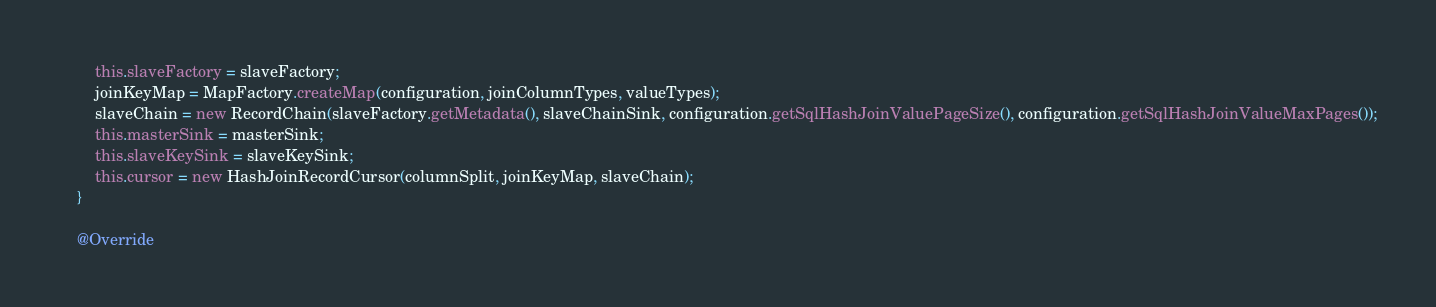<code> <loc_0><loc_0><loc_500><loc_500><_Java_>        this.slaveFactory = slaveFactory;
        joinKeyMap = MapFactory.createMap(configuration, joinColumnTypes, valueTypes);
        slaveChain = new RecordChain(slaveFactory.getMetadata(), slaveChainSink, configuration.getSqlHashJoinValuePageSize(), configuration.getSqlHashJoinValueMaxPages());
        this.masterSink = masterSink;
        this.slaveKeySink = slaveKeySink;
        this.cursor = new HashJoinRecordCursor(columnSplit, joinKeyMap, slaveChain);
    }

    @Override</code> 